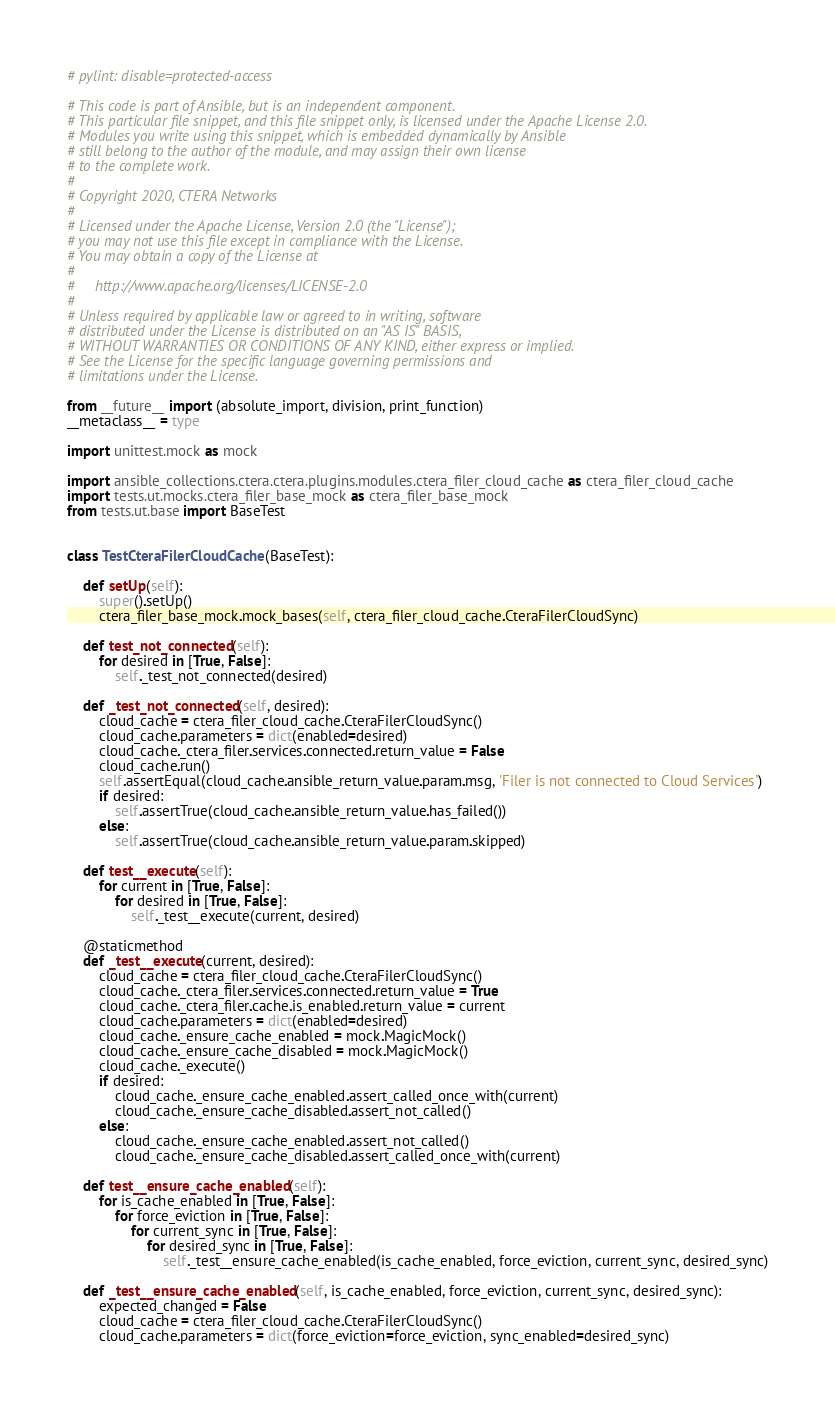Convert code to text. <code><loc_0><loc_0><loc_500><loc_500><_Python_># pylint: disable=protected-access

# This code is part of Ansible, but is an independent component.
# This particular file snippet, and this file snippet only, is licensed under the Apache License 2.0.
# Modules you write using this snippet, which is embedded dynamically by Ansible
# still belong to the author of the module, and may assign their own license
# to the complete work.
#
# Copyright 2020, CTERA Networks
#
# Licensed under the Apache License, Version 2.0 (the "License");
# you may not use this file except in compliance with the License.
# You may obtain a copy of the License at
#
#     http://www.apache.org/licenses/LICENSE-2.0
#
# Unless required by applicable law or agreed to in writing, software
# distributed under the License is distributed on an "AS IS" BASIS,
# WITHOUT WARRANTIES OR CONDITIONS OF ANY KIND, either express or implied.
# See the License for the specific language governing permissions and
# limitations under the License.

from __future__ import (absolute_import, division, print_function)
__metaclass__ = type

import unittest.mock as mock

import ansible_collections.ctera.ctera.plugins.modules.ctera_filer_cloud_cache as ctera_filer_cloud_cache
import tests.ut.mocks.ctera_filer_base_mock as ctera_filer_base_mock
from tests.ut.base import BaseTest


class TestCteraFilerCloudCache(BaseTest):

    def setUp(self):
        super().setUp()
        ctera_filer_base_mock.mock_bases(self, ctera_filer_cloud_cache.CteraFilerCloudSync)

    def test_not_connected(self):
        for desired in [True, False]:
            self._test_not_connected(desired)

    def _test_not_connected(self, desired):
        cloud_cache = ctera_filer_cloud_cache.CteraFilerCloudSync()
        cloud_cache.parameters = dict(enabled=desired)
        cloud_cache._ctera_filer.services.connected.return_value = False
        cloud_cache.run()
        self.assertEqual(cloud_cache.ansible_return_value.param.msg, 'Filer is not connected to Cloud Services')
        if desired:
            self.assertTrue(cloud_cache.ansible_return_value.has_failed())
        else:
            self.assertTrue(cloud_cache.ansible_return_value.param.skipped)

    def test__execute(self):
        for current in [True, False]:
            for desired in [True, False]:
                self._test__execute(current, desired)

    @staticmethod
    def _test__execute(current, desired):
        cloud_cache = ctera_filer_cloud_cache.CteraFilerCloudSync()
        cloud_cache._ctera_filer.services.connected.return_value = True
        cloud_cache._ctera_filer.cache.is_enabled.return_value = current
        cloud_cache.parameters = dict(enabled=desired)
        cloud_cache._ensure_cache_enabled = mock.MagicMock()
        cloud_cache._ensure_cache_disabled = mock.MagicMock()
        cloud_cache._execute()
        if desired:
            cloud_cache._ensure_cache_enabled.assert_called_once_with(current)
            cloud_cache._ensure_cache_disabled.assert_not_called()
        else:
            cloud_cache._ensure_cache_enabled.assert_not_called()
            cloud_cache._ensure_cache_disabled.assert_called_once_with(current)

    def test__ensure_cache_enabled(self):
        for is_cache_enabled in [True, False]:
            for force_eviction in [True, False]:
                for current_sync in [True, False]:
                    for desired_sync in [True, False]:
                        self._test__ensure_cache_enabled(is_cache_enabled, force_eviction, current_sync, desired_sync)

    def _test__ensure_cache_enabled(self, is_cache_enabled, force_eviction, current_sync, desired_sync):
        expected_changed = False
        cloud_cache = ctera_filer_cloud_cache.CteraFilerCloudSync()
        cloud_cache.parameters = dict(force_eviction=force_eviction, sync_enabled=desired_sync)</code> 